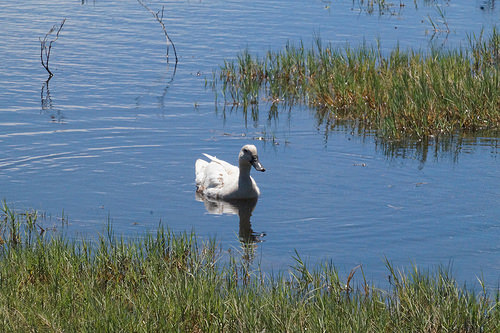<image>
Can you confirm if the water is behind the grass? Yes. From this viewpoint, the water is positioned behind the grass, with the grass partially or fully occluding the water. Where is the duck in relation to the grass? Is it above the grass? No. The duck is not positioned above the grass. The vertical arrangement shows a different relationship. 